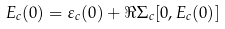Convert formula to latex. <formula><loc_0><loc_0><loc_500><loc_500>E _ { c } ( 0 ) = \varepsilon _ { c } ( 0 ) + \Re \Sigma _ { c } [ 0 , E _ { c } ( 0 ) ]</formula> 